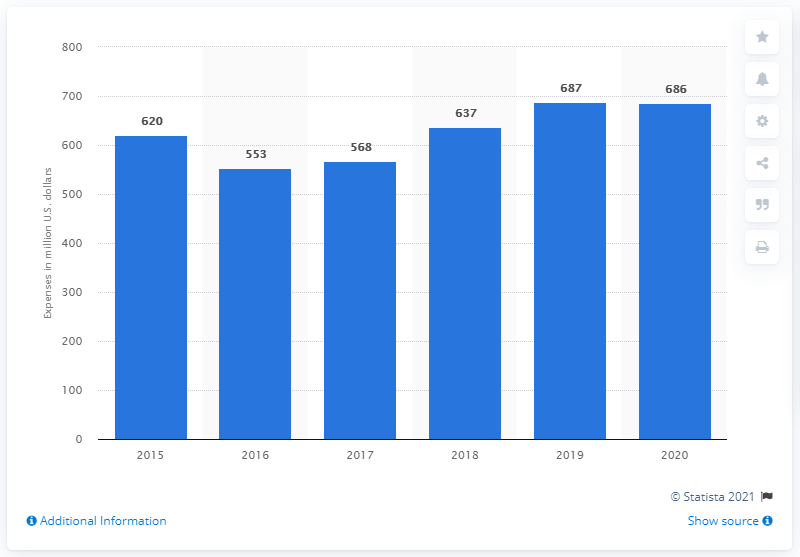Draw attention to some important aspects in this diagram. In 2020, Motorola reported spending 686 million US dollars on research and development. 